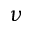<formula> <loc_0><loc_0><loc_500><loc_500>\nu</formula> 